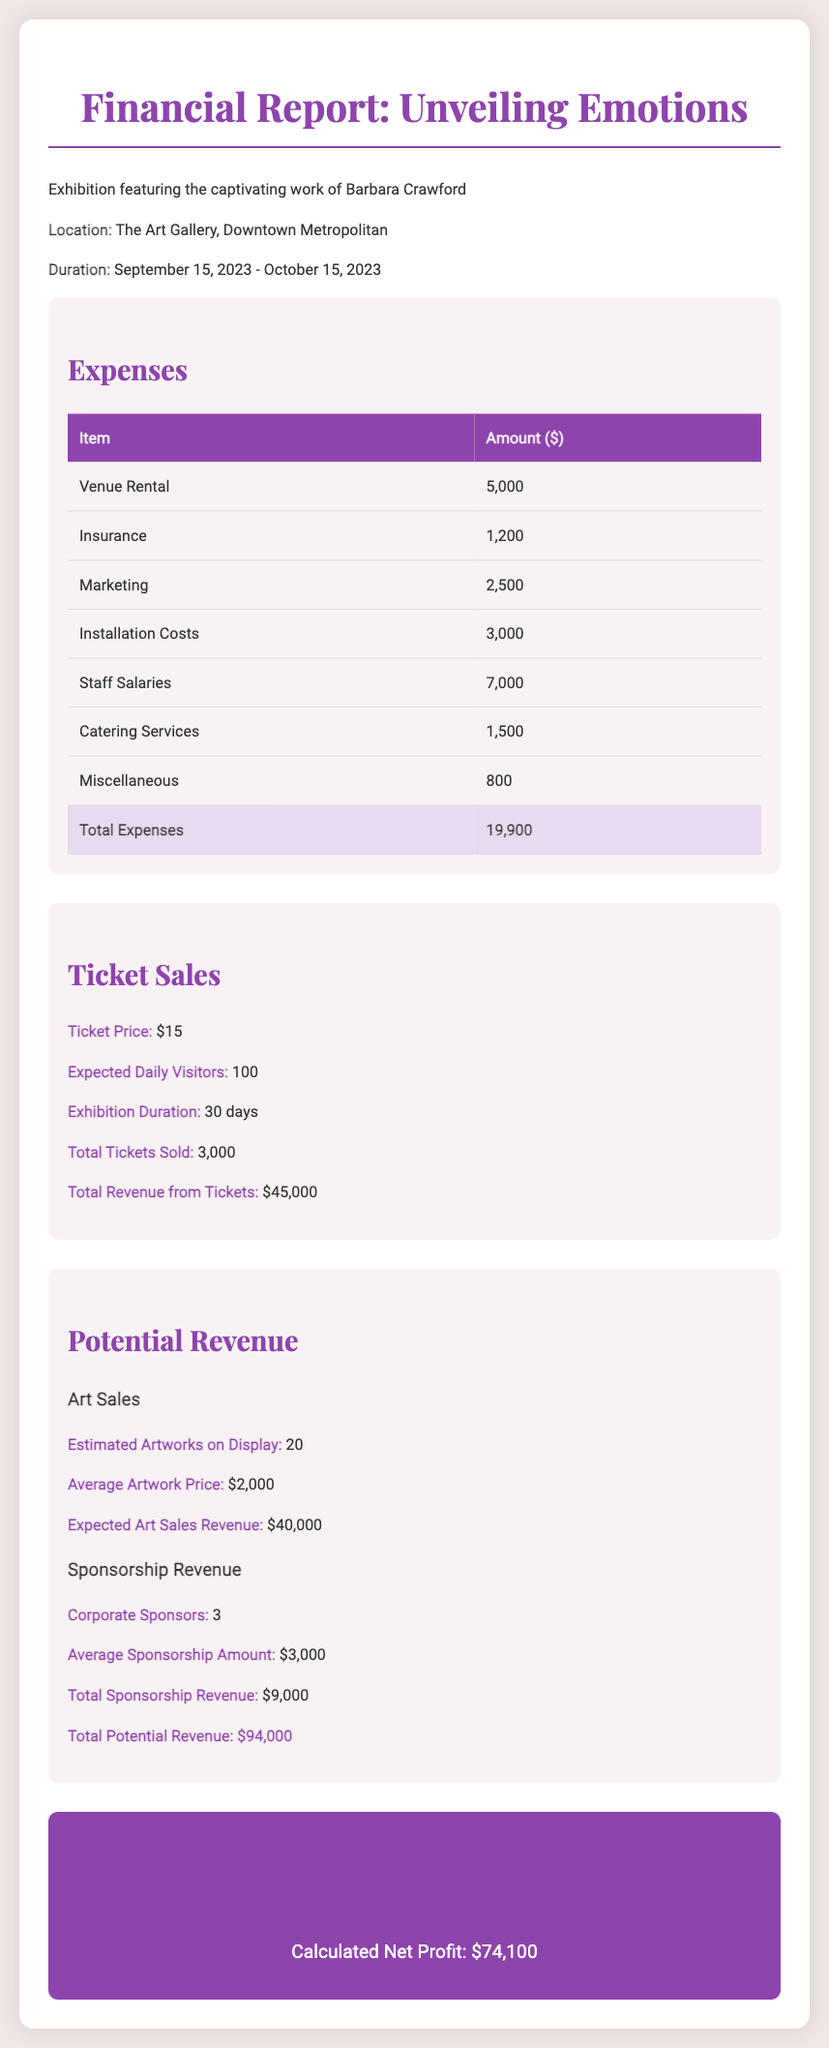What is the total expenses? The total expenses are listed at the end of the expenses section in the document.
Answer: $19,900 What is the ticket price? The ticket price is specified in the ticket sales section of the document.
Answer: $15 How many expected daily visitors are there? The expected daily visitors are mentioned in the ticket sales section.
Answer: 100 What is the expected art sales revenue? The expected art sales revenue is detailed under the potential revenue section related to art sales.
Answer: $40,000 How many corporate sponsors are there? The number of corporate sponsors is indicated in the sponsorship revenue subsection.
Answer: 3 What is the calculated net profit? The net profit is shown in the final section of the document.
Answer: $74,100 What is the average artwork price? The average artwork price is provided in the potential revenue section under art sales.
Answer: $2,000 What is the total potential revenue? The total potential revenue is clearly stated in the potential revenue section of the document.
Answer: $94,000 What is the exhibition duration? The duration of the exhibition is mentioned at the beginning of the document.
Answer: September 15, 2023 - October 15, 2023 